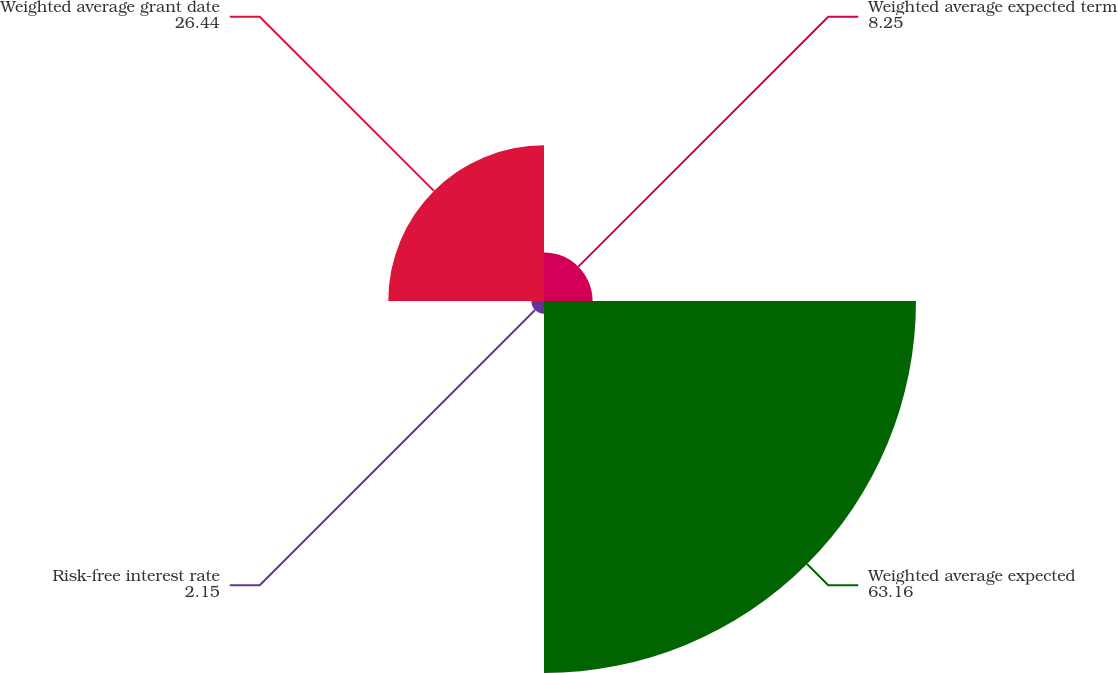Convert chart. <chart><loc_0><loc_0><loc_500><loc_500><pie_chart><fcel>Weighted average expected term<fcel>Weighted average expected<fcel>Risk-free interest rate<fcel>Weighted average grant date<nl><fcel>8.25%<fcel>63.16%<fcel>2.15%<fcel>26.44%<nl></chart> 